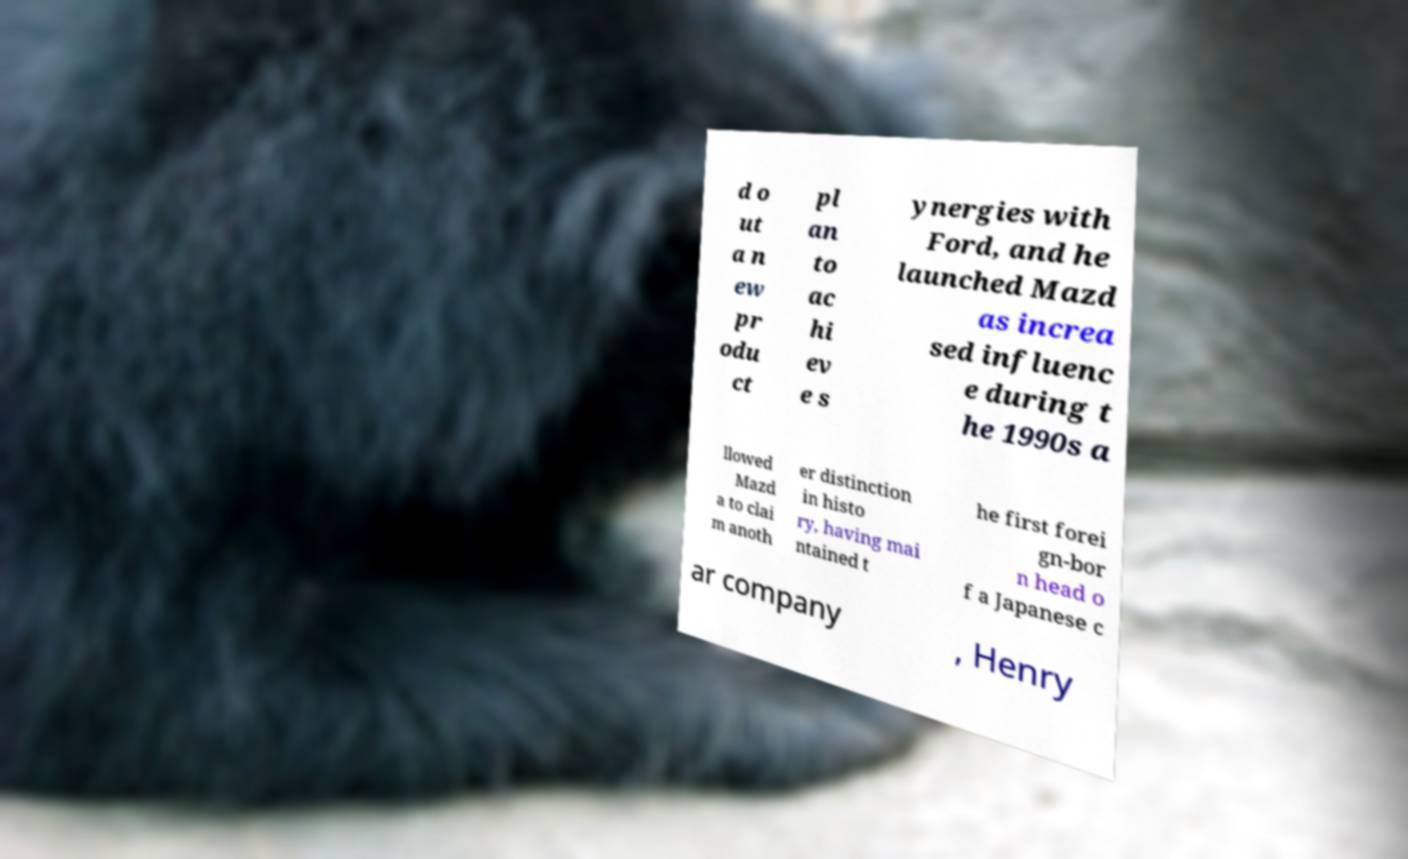Please identify and transcribe the text found in this image. d o ut a n ew pr odu ct pl an to ac hi ev e s ynergies with Ford, and he launched Mazd as increa sed influenc e during t he 1990s a llowed Mazd a to clai m anoth er distinction in histo ry, having mai ntained t he first forei gn-bor n head o f a Japanese c ar company , Henry 